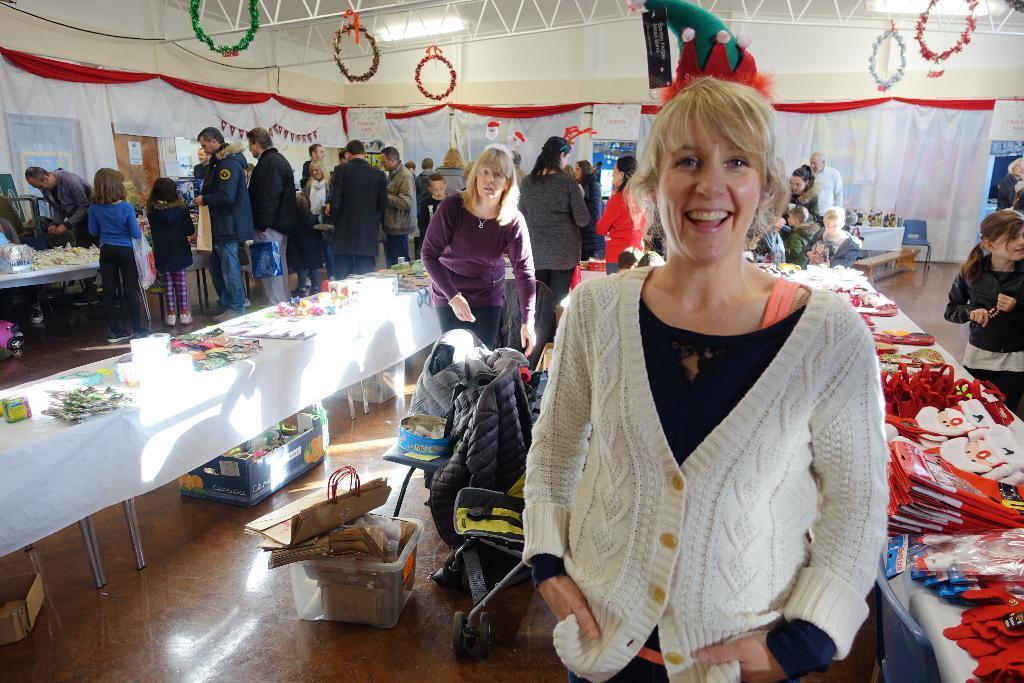Describe this image in one or two sentences. In this picture there is an old women wearing a white color sweater standing in the front, smiling and giving a pose into the camera. Behind we can see the exhibition hall with some tables and selling products. Behind there are some persons doing shopping. In the background we can see the white curtains and some decorative round ribbons. 